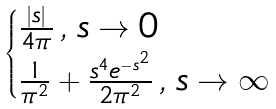<formula> <loc_0><loc_0><loc_500><loc_500>\begin{cases} \frac { | s | } { 4 \pi } \, , \, s \to 0 \\ \frac { 1 } { \pi ^ { 2 } } + \frac { s ^ { 4 } e ^ { - s ^ { 2 } } } { 2 \pi ^ { 2 } } \, , \, s \to \infty \end{cases}</formula> 